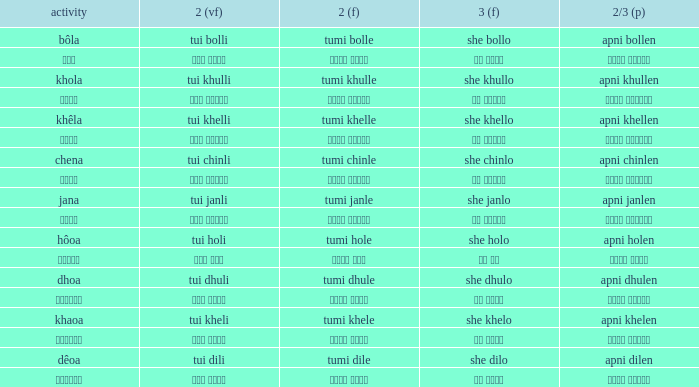What is the verb for তুমি খেলে? খাওয়া. Parse the table in full. {'header': ['activity', '2 (vf)', '2 (f)', '3 (f)', '2/3 (p)'], 'rows': [['bôla', 'tui bolli', 'tumi bolle', 'she bollo', 'apni bollen'], ['বলা', 'তুই বললি', 'তুমি বললে', 'সে বললো', 'আপনি বললেন'], ['khola', 'tui khulli', 'tumi khulle', 'she khullo', 'apni khullen'], ['খোলা', 'তুই খুললি', 'তুমি খুললে', 'সে খুললো', 'আপনি খুললেন'], ['khêla', 'tui khelli', 'tumi khelle', 'she khello', 'apni khellen'], ['খেলে', 'তুই খেললি', 'তুমি খেললে', 'সে খেললো', 'আপনি খেললেন'], ['chena', 'tui chinli', 'tumi chinle', 'she chinlo', 'apni chinlen'], ['চেনা', 'তুই চিনলি', 'তুমি চিনলে', 'সে চিনলো', 'আপনি চিনলেন'], ['jana', 'tui janli', 'tumi janle', 'she janlo', 'apni janlen'], ['জানা', 'তুই জানলি', 'তুমি জানলে', 'সে জানলে', 'আপনি জানলেন'], ['hôoa', 'tui holi', 'tumi hole', 'she holo', 'apni holen'], ['হওয়া', 'তুই হলি', 'তুমি হলে', 'সে হল', 'আপনি হলেন'], ['dhoa', 'tui dhuli', 'tumi dhule', 'she dhulo', 'apni dhulen'], ['ধোওয়া', 'তুই ধুলি', 'তুমি ধুলে', 'সে ধুলো', 'আপনি ধুলেন'], ['khaoa', 'tui kheli', 'tumi khele', 'she khelo', 'apni khelen'], ['খাওয়া', 'তুই খেলি', 'তুমি খেলে', 'সে খেলো', 'আপনি খেলেন'], ['dêoa', 'tui dili', 'tumi dile', 'she dilo', 'apni dilen'], ['দেওয়া', 'তুই দিলি', 'তুমি দিলে', 'সে দিলো', 'আপনি দিলেন']]} 